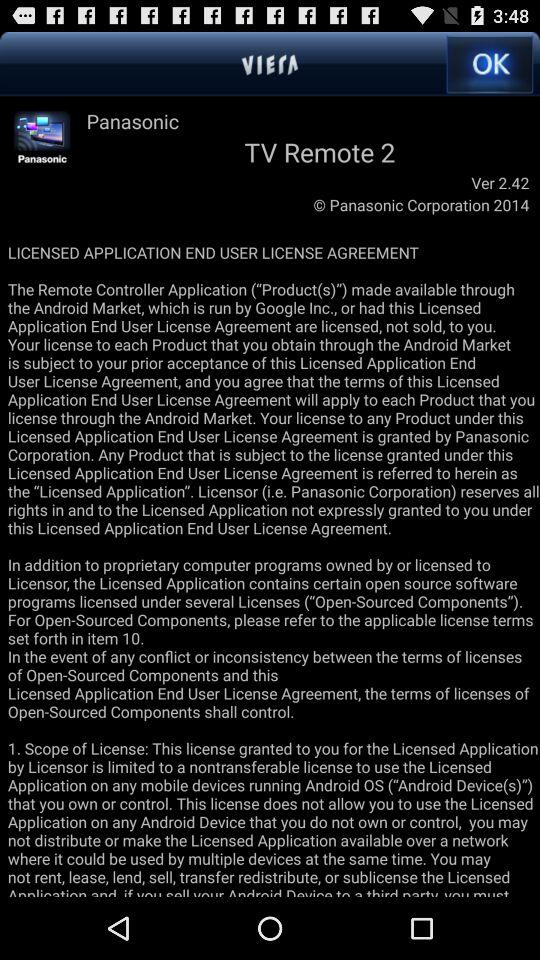What is the brand name? The brand name is "Panasonic". 